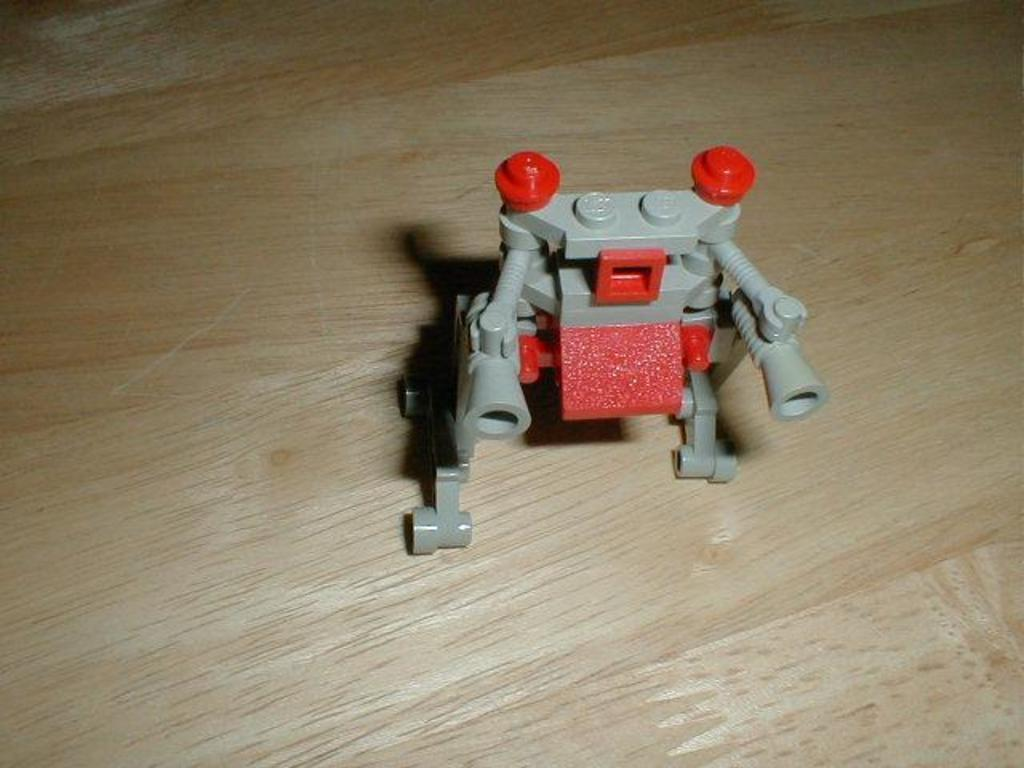What can be seen in the image? There is an object in the image. Can you describe the surface on which the object is placed? The object is placed on a wooden board. What type of government is depicted in the image? There is no depiction of a government in the image; it only features an object placed on a wooden board. How many ladybugs can be seen crawling on the object in the image? There are no ladybugs present in the image. 